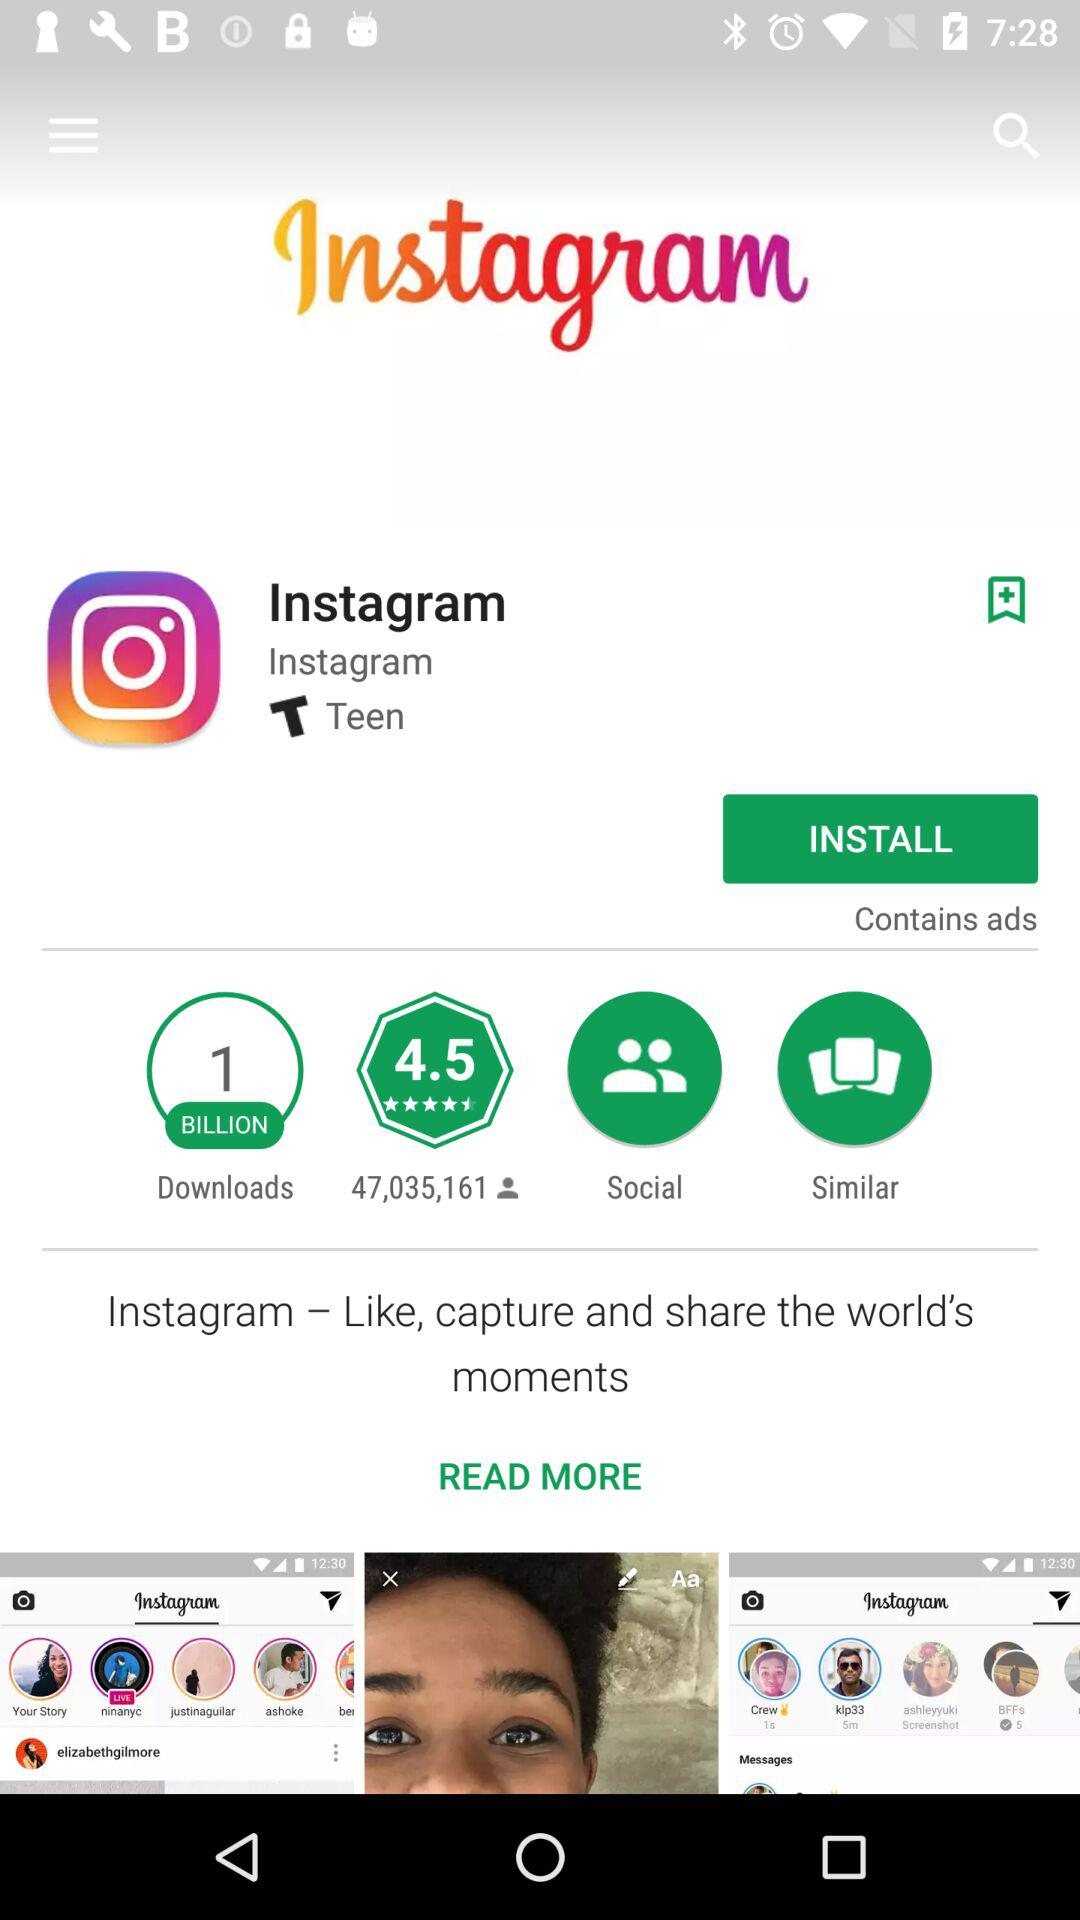How many downloads does the application have? The application has 1 billion downloads. 